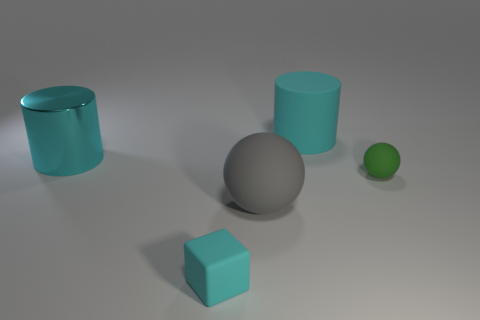Add 4 rubber cubes. How many objects exist? 9 Subtract all spheres. How many objects are left? 3 Add 5 large cyan cylinders. How many large cyan cylinders are left? 7 Add 4 cylinders. How many cylinders exist? 6 Subtract 0 yellow cylinders. How many objects are left? 5 Subtract all big metallic cylinders. Subtract all large blue rubber objects. How many objects are left? 4 